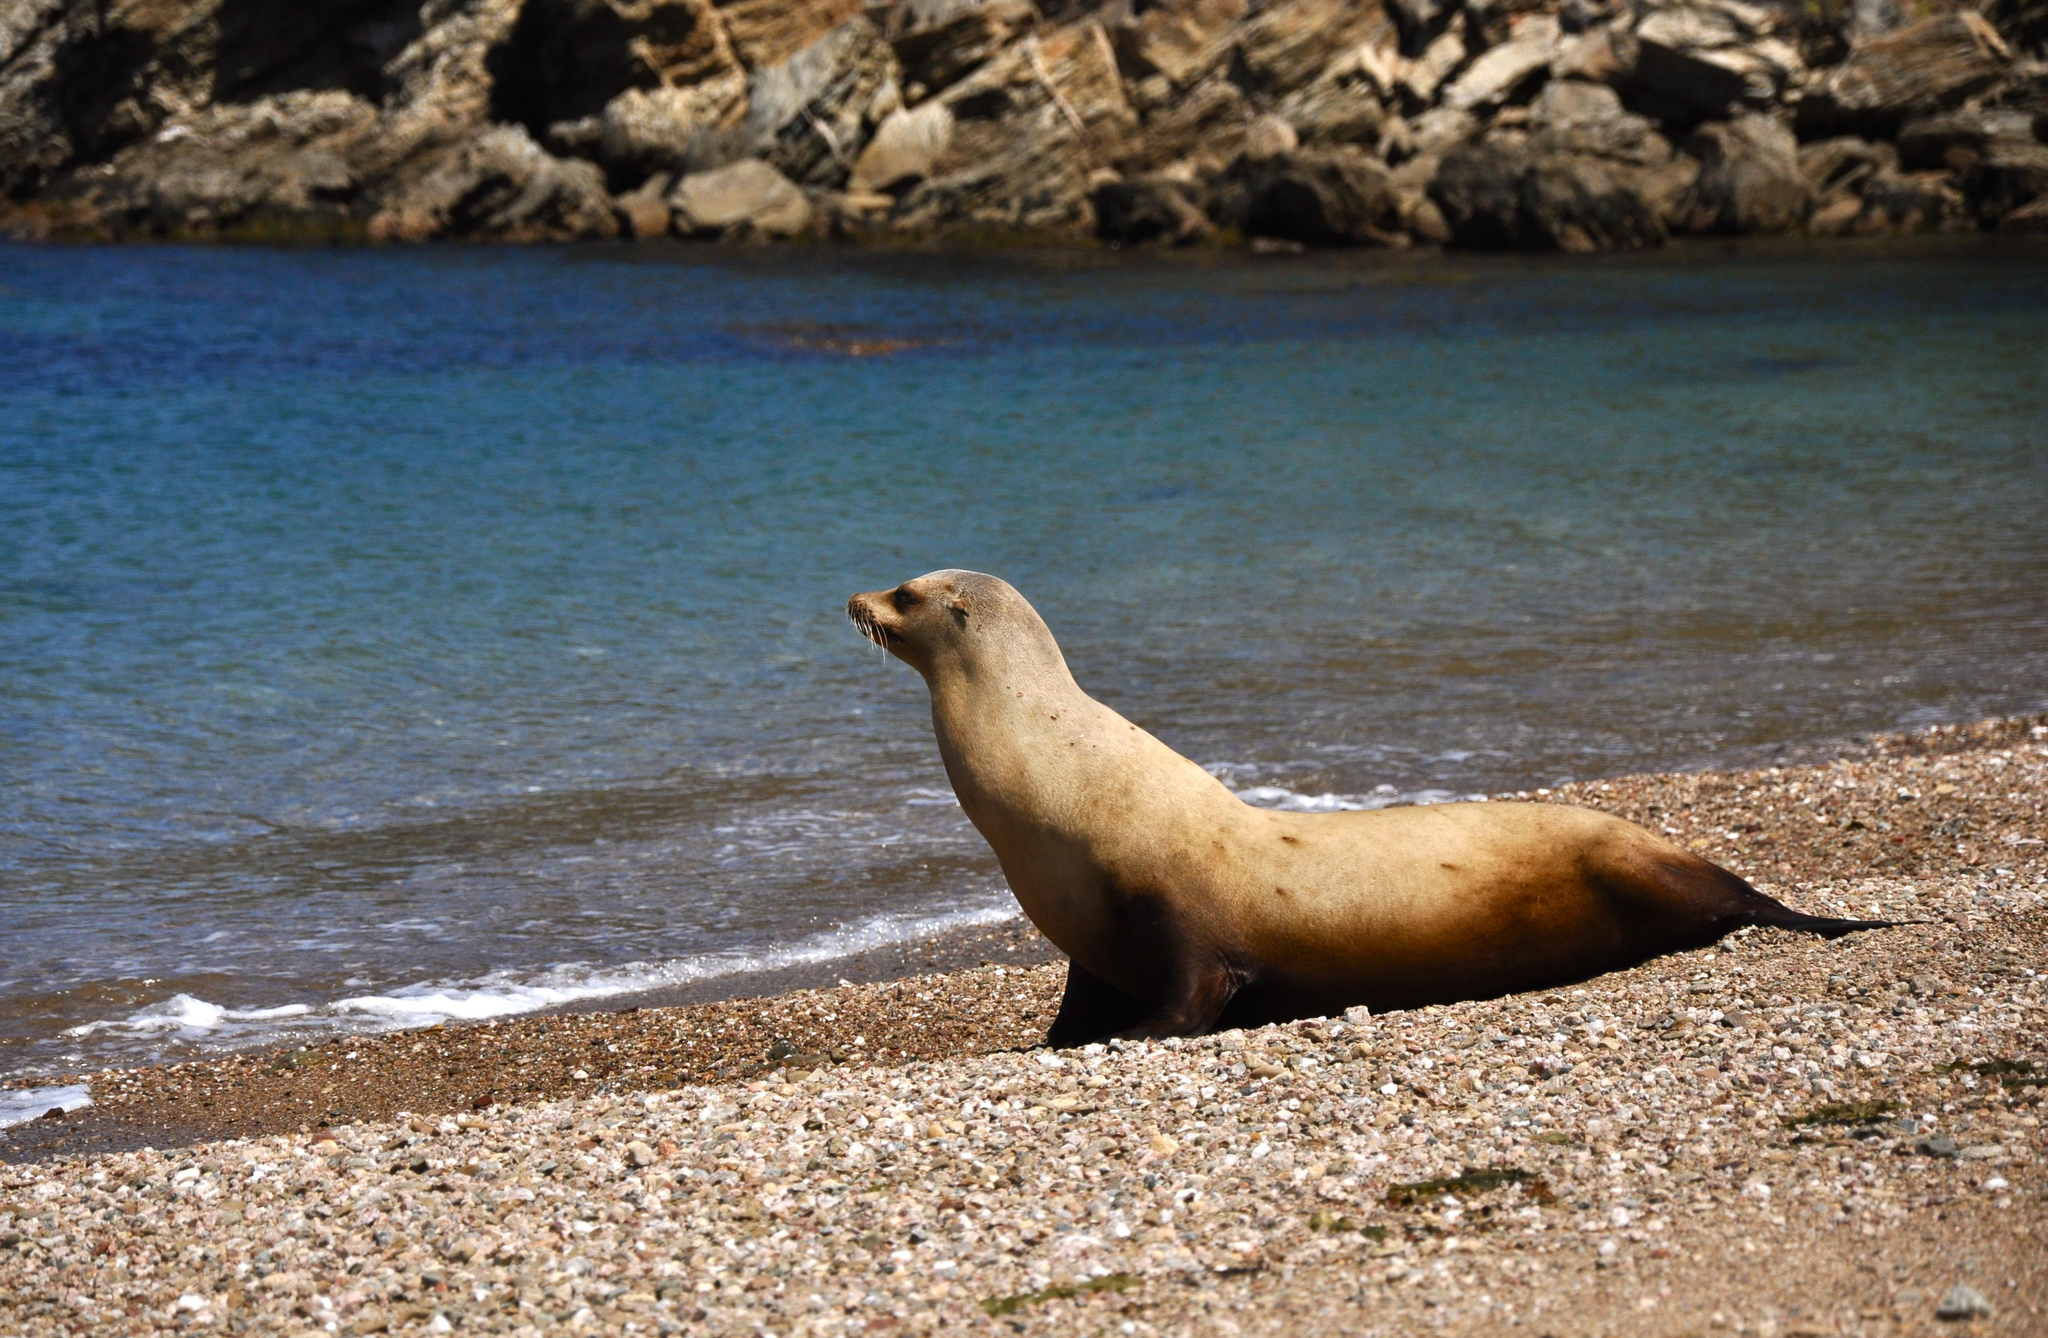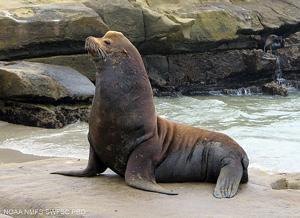The first image is the image on the left, the second image is the image on the right. Considering the images on both sides, is "A tawny-colored seal is sleeping in at least one of the images." valid? Answer yes or no. No. The first image is the image on the left, the second image is the image on the right. Analyze the images presented: Is the assertion "There are no more than two seals." valid? Answer yes or no. Yes. 